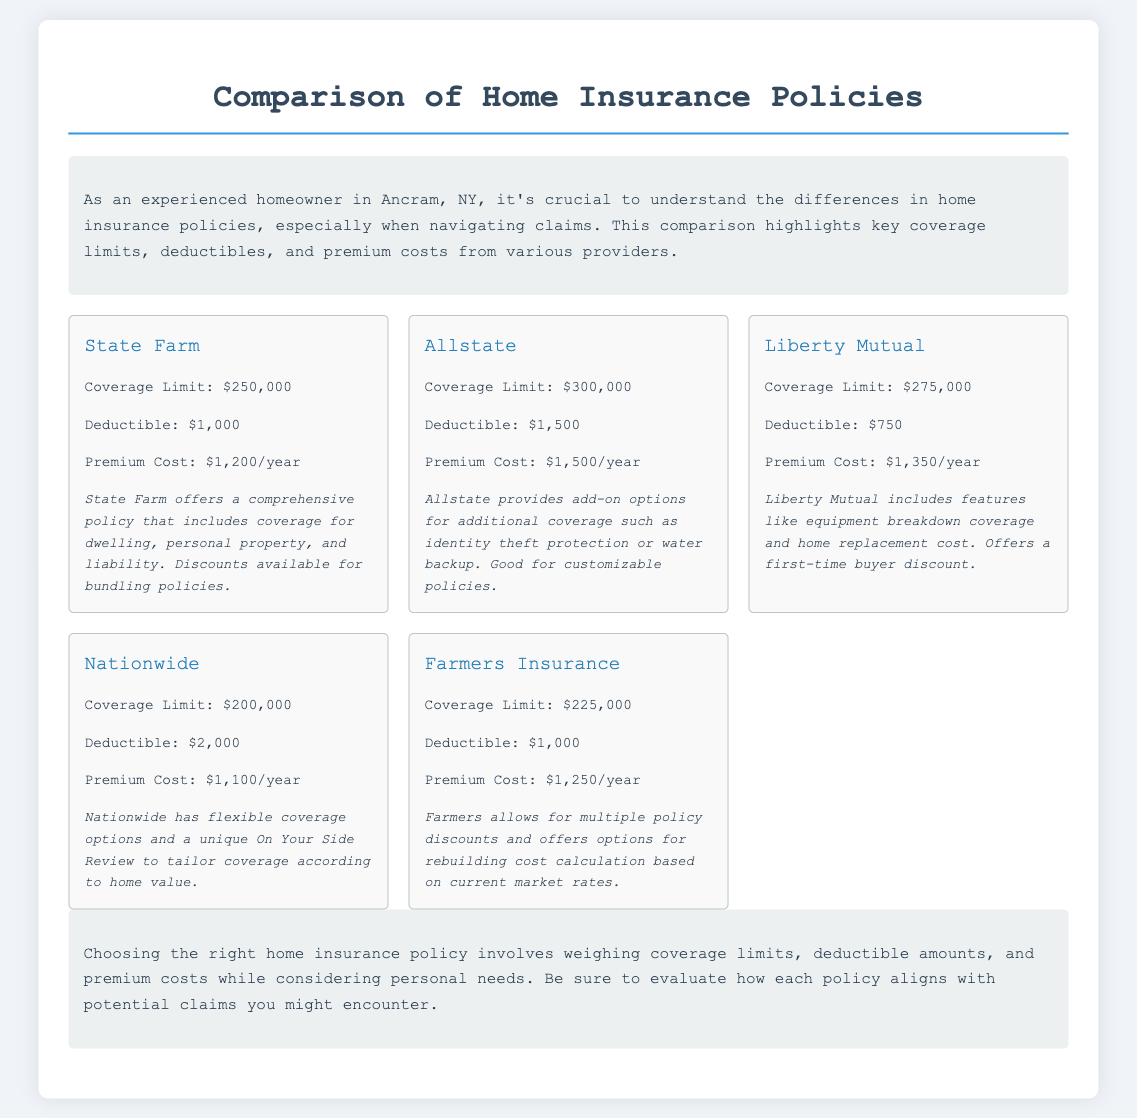What is the coverage limit for State Farm? The coverage limit for State Farm is stated directly in the document as $250,000.
Answer: $250,000 What is the deductible for Allstate? The deductible for Allstate is explicitly mentioned in the document as $1,500.
Answer: $1,500 Which provider offers the lowest premium cost? To find the provider with the lowest premium cost, you need to compare the listed premium costs, which shows Nationwide offers the lowest at $1,100 per year.
Answer: Nationwide What coverage limit does Liberty Mutual offer? The document specifies that Liberty Mutual has a coverage limit of $275,000.
Answer: $275,000 How much is the premium cost for Farmers Insurance? The premium cost for Farmers Insurance is presented in the document as $1,250 per year.
Answer: $1,250 Which insurance provider has the highest coverage limit? By evaluating the coverage limits mentioned, Allstate has the highest limit at $300,000.
Answer: Allstate Which two providers have a deductible of $1,000? The document indicates that State Farm and Farmers Insurance both have a deductible of $1,000.
Answer: State Farm and Farmers Insurance Does Nationwide offer flexible coverage options? The document notes that Nationwide has flexible coverage options.
Answer: Yes What is the unique feature offered by Nationwide? The document mentions a unique feature of Nationwide is the "On Your Side Review."
Answer: On Your Side Review 